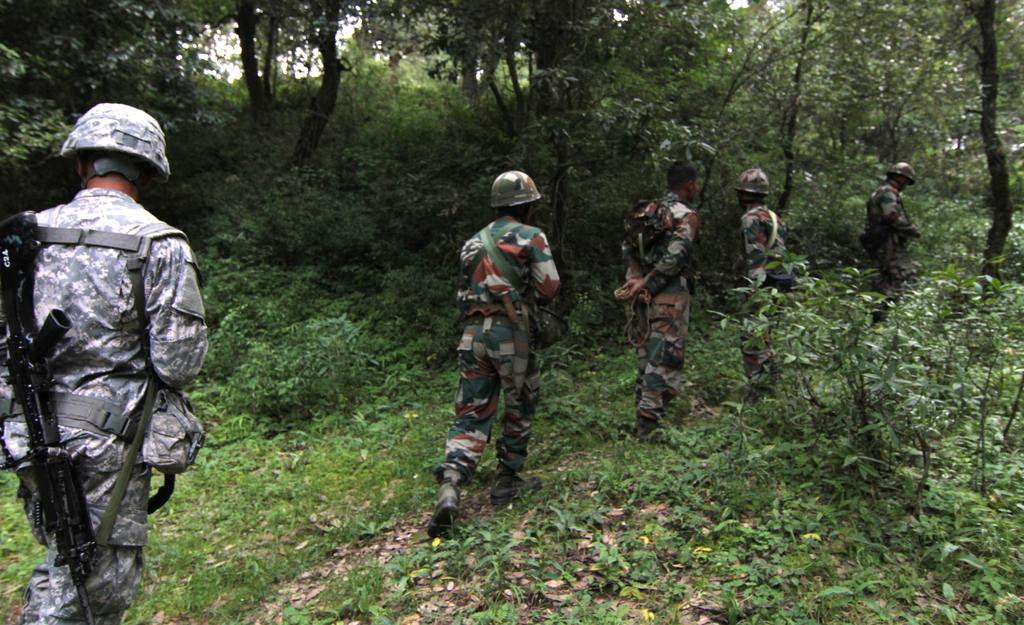How many soldiers are present in the image? There are 5 soldiers in the image. What are the soldiers doing in the image? The soldiers are walking in a jungle. What can be seen in the background of the image? There are trees surrounding the soldiers. What letter is the soldier holding in the image? There is no soldier holding a letter in the image. What type of crack can be seen on the ground in the image? There is no crack visible on the ground in the image. 